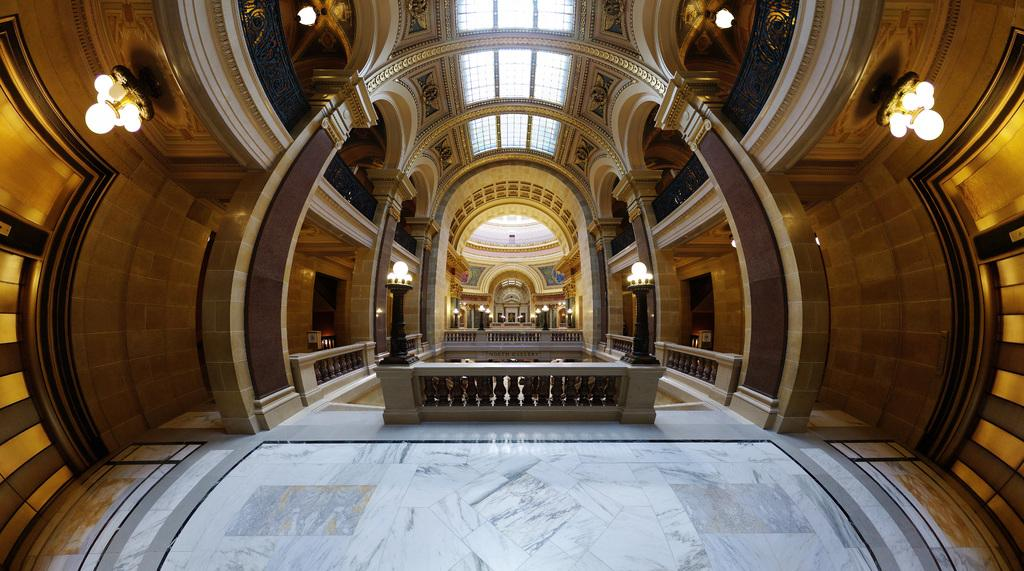Where is the location of the image? The image is inside a building. What can be seen in the building that provides illumination? There are lights in the building. What structural elements are present in the building? There are walls and pillars in the building. What type of barrier can be seen in the building? There is a fence in the building. What covers the top of the building? There is a roof in the building. What type of linen is draped over the pillars in the image? There is no linen draped over the pillars in the image; the pillars are visible without any fabric covering them. 